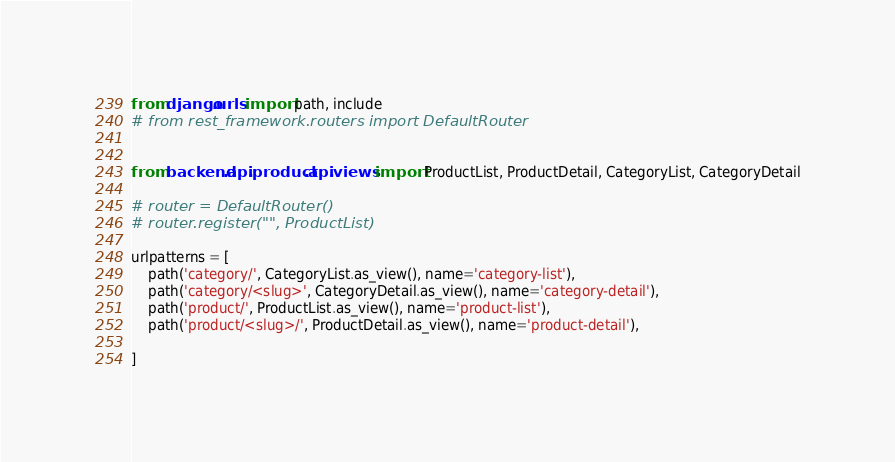Convert code to text. <code><loc_0><loc_0><loc_500><loc_500><_Python_>from django.urls import path, include
# from rest_framework.routers import DefaultRouter


from backend.api.product.api.views import ProductList, ProductDetail, CategoryList, CategoryDetail

# router = DefaultRouter()
# router.register("", ProductList)

urlpatterns = [
    path('category/', CategoryList.as_view(), name='category-list'),
    path('category/<slug>', CategoryDetail.as_view(), name='category-detail'),
    path('product/', ProductList.as_view(), name='product-list'),
    path('product/<slug>/', ProductDetail.as_view(), name='product-detail'),

]
</code> 